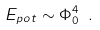<formula> <loc_0><loc_0><loc_500><loc_500>E _ { p o t } \sim \Phi _ { 0 } ^ { 4 } \ .</formula> 